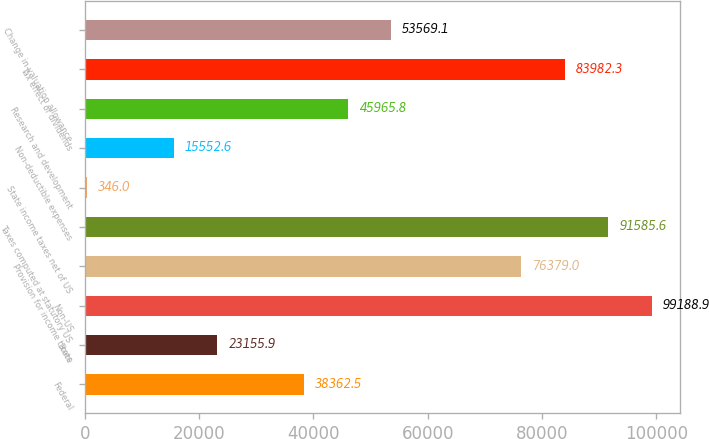Convert chart. <chart><loc_0><loc_0><loc_500><loc_500><bar_chart><fcel>Federal<fcel>State<fcel>Non-US<fcel>Provision for income taxes<fcel>Taxes computed at statutory US<fcel>State income taxes net of US<fcel>Non-deductible expenses<fcel>Research and development<fcel>Tax effect of dividends<fcel>Change in valuation allowance<nl><fcel>38362.5<fcel>23155.9<fcel>99188.9<fcel>76379<fcel>91585.6<fcel>346<fcel>15552.6<fcel>45965.8<fcel>83982.3<fcel>53569.1<nl></chart> 